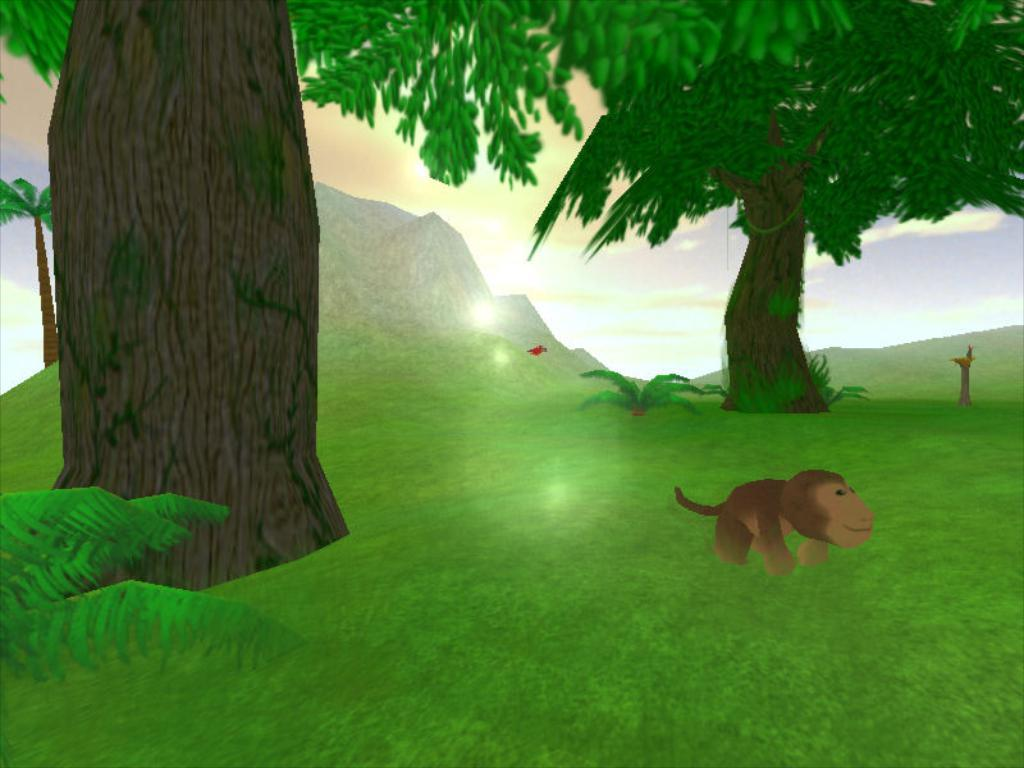What type of image is shown in the picture? The image is a graphical image. What cartoon character can be seen in the image? There is a cartoon of a monkey in the image. What other cartoon elements are present in the image? There are cartoon trees and cartoon grass in the image. What is depicted in the background of the image? The sky is depicted in the image. What type of stove is featured in the advertisement in the image? There is no stove or advertisement present in the image; it is a graphical image featuring a cartoon monkey, trees, grass, and the sky. 